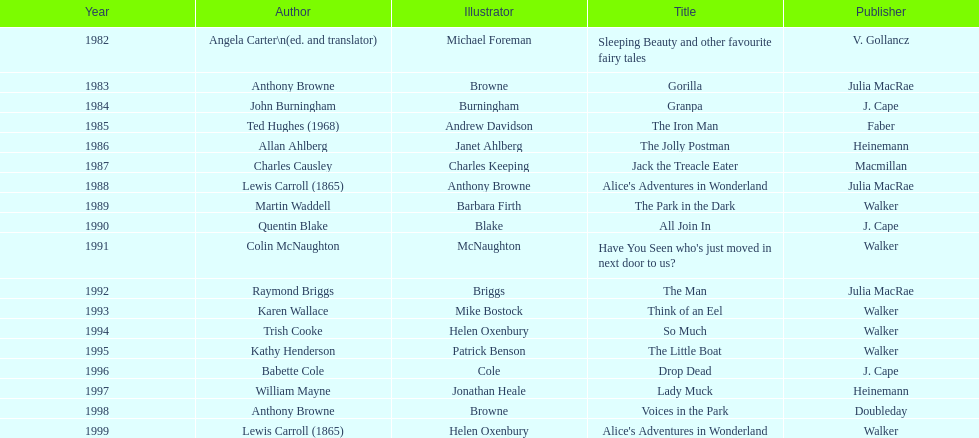Which illustrator was responsible for the last award winner? Helen Oxenbury. 